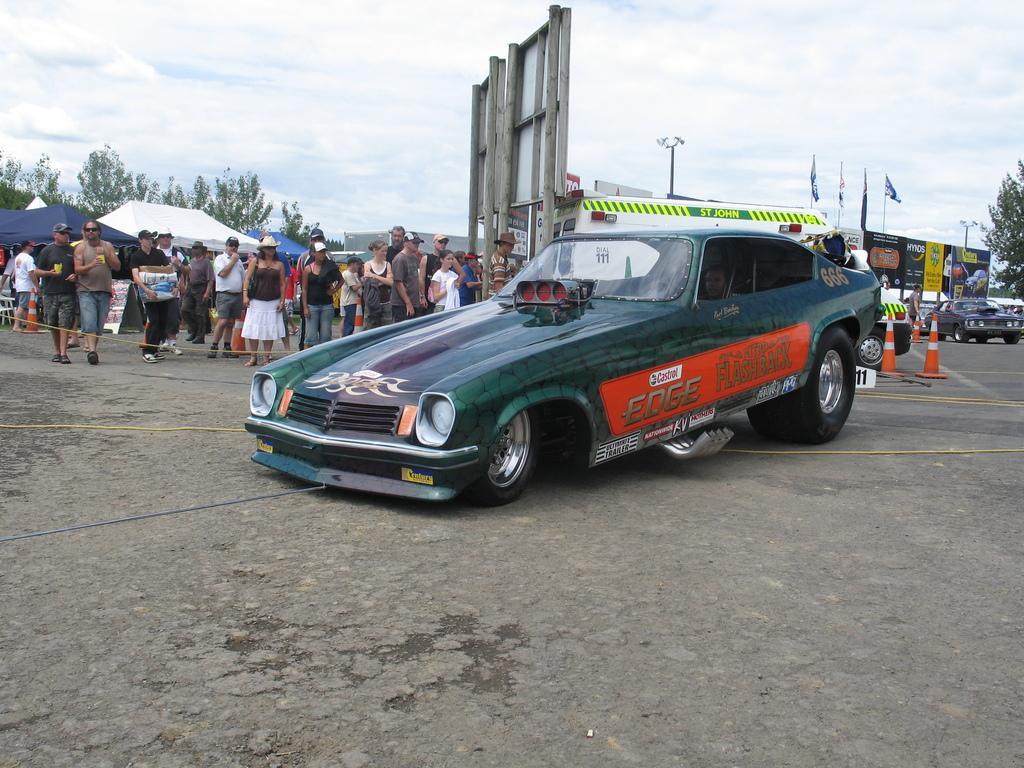How would you summarize this image in a sentence or two? The picture is taken outside a city on the road. In the foreground of the picture there is a car. In the center of the picture there are people, tents, hoardings, flags, cars, indicators and a street. light Sky is cloudy. 